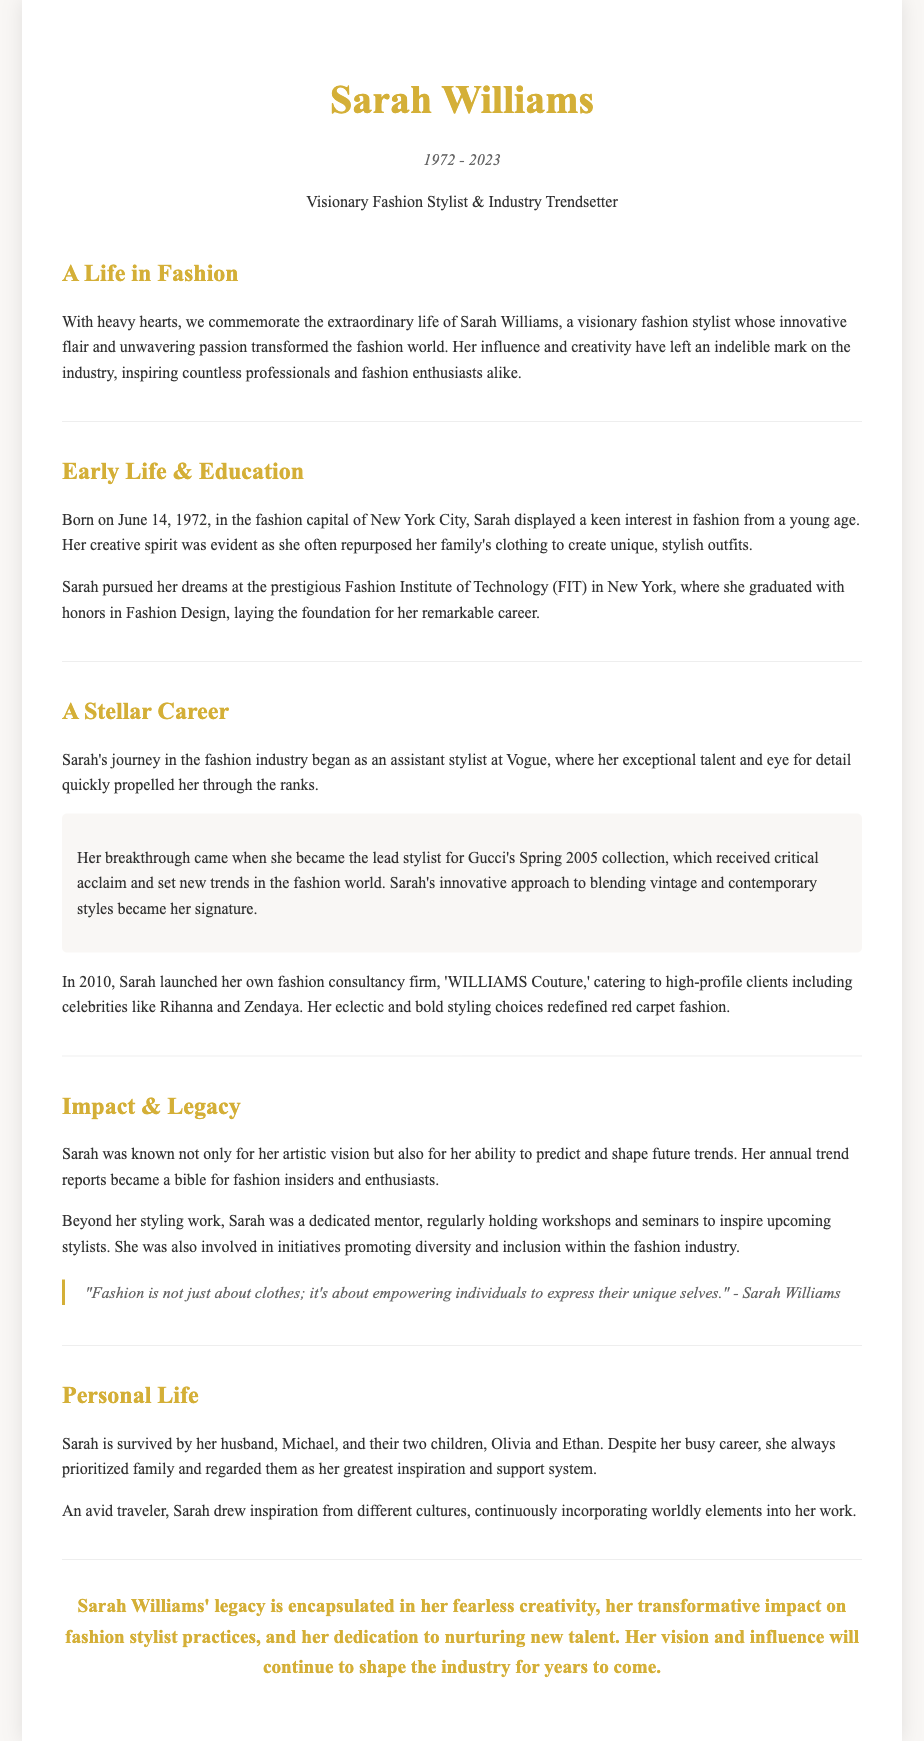What was Sarah Williams' profession? The document states that she was a Visionary Fashion Stylist & Industry Trendsetter.
Answer: Fashion Stylist When was Sarah Williams born? The document mentions her birth date as June 14, 1972.
Answer: June 14, 1972 What was the name of Sarah's fashion consultancy firm? The document refers to her fashion consultancy firm as 'WILLIAMS Couture.'
Answer: WILLIAMS Couture Which celebrity did Sarah style for her consultancy? The document lists Rihanna as one of the high-profile clients.
Answer: Rihanna What significant role did Sarah have at Vogue? The document states she was an assistant stylist at Vogue, and later became the lead stylist.
Answer: Assistant stylist What did Sarah emphasize in her quote? Her quote highlights that fashion is about empowering individuals.
Answer: Empowering individuals How many children did Sarah have? The document specifies that she had two children, Olivia and Ethan.
Answer: Two What did Sarah prioritize despite her busy career? The document indicates that she prioritized family.
Answer: Family What aspect of fashion did Sarah's trend reports cover? The document describes them as a guide for fashion insiders and enthusiasts.
Answer: Future trends 